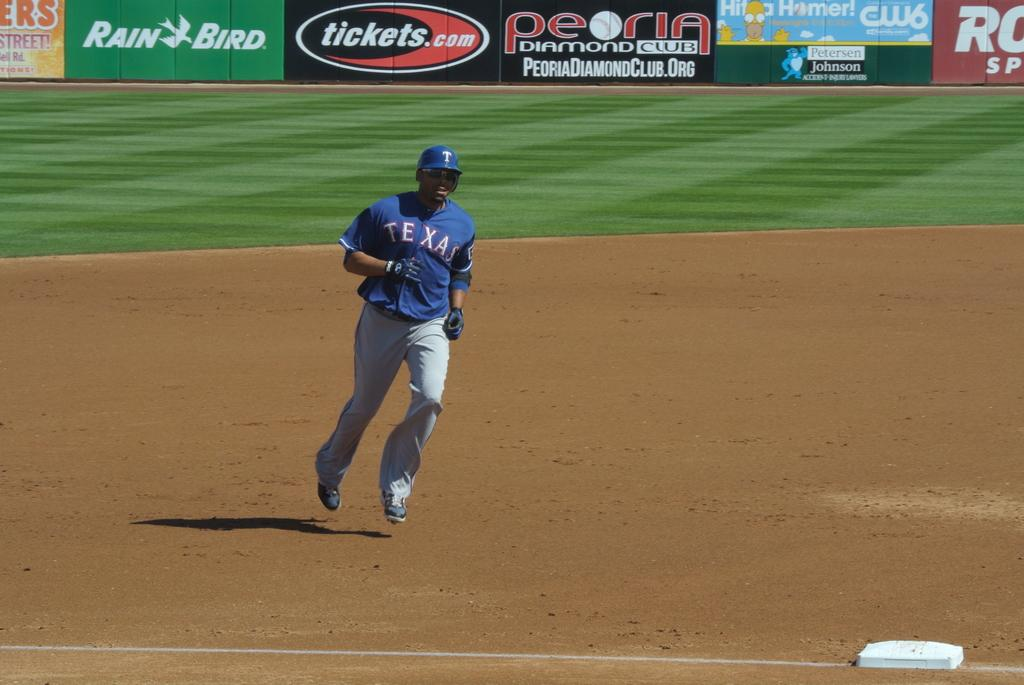Provide a one-sentence caption for the provided image. Baseball player from team Texas is running to the third base. 